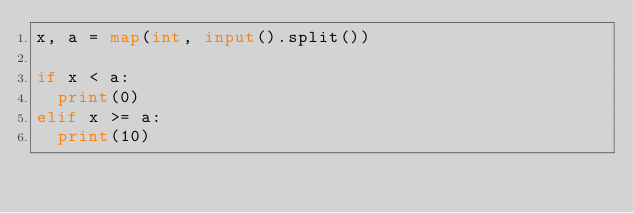<code> <loc_0><loc_0><loc_500><loc_500><_Python_>x, a = map(int, input().split())

if x < a:
	print(0)
elif x >= a:
	print(10)</code> 